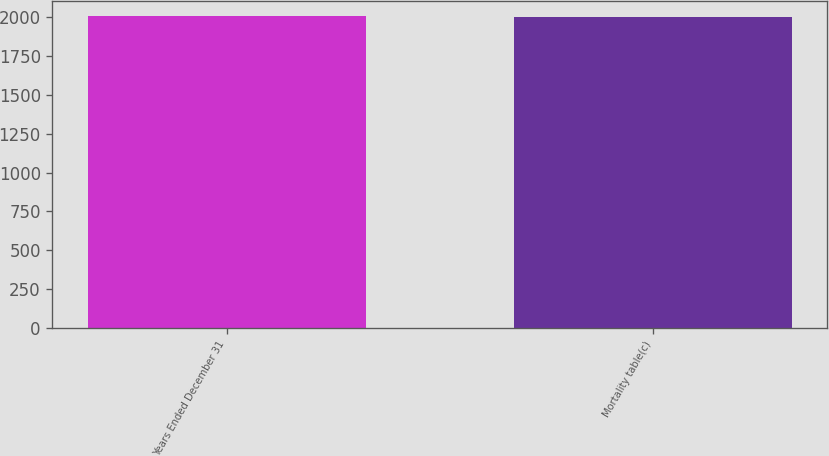Convert chart. <chart><loc_0><loc_0><loc_500><loc_500><bar_chart><fcel>Years Ended December 31<fcel>Mortality table(c)<nl><fcel>2005<fcel>2000<nl></chart> 